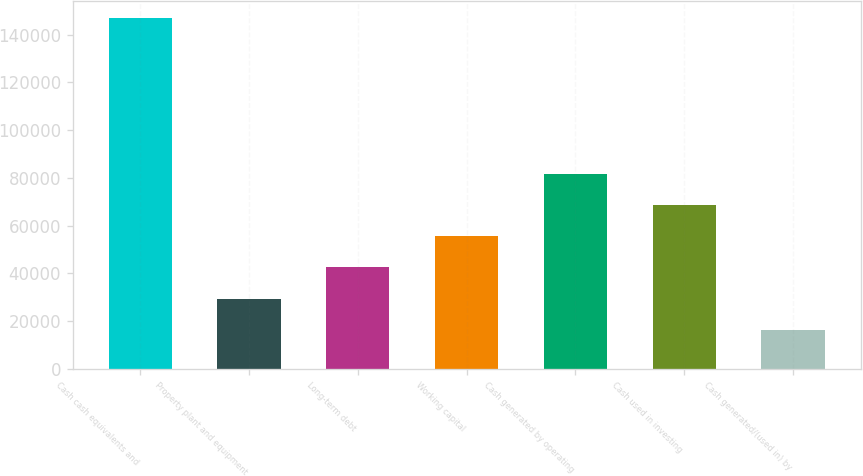Convert chart. <chart><loc_0><loc_0><loc_500><loc_500><bar_chart><fcel>Cash cash equivalents and<fcel>Property plant and equipment<fcel>Long-term debt<fcel>Working capital<fcel>Cash generated by operating<fcel>Cash used in investing<fcel>Cash generated/(used in) by<nl><fcel>146761<fcel>29417.2<fcel>42455.4<fcel>55493.6<fcel>81570<fcel>68531.8<fcel>16379<nl></chart> 